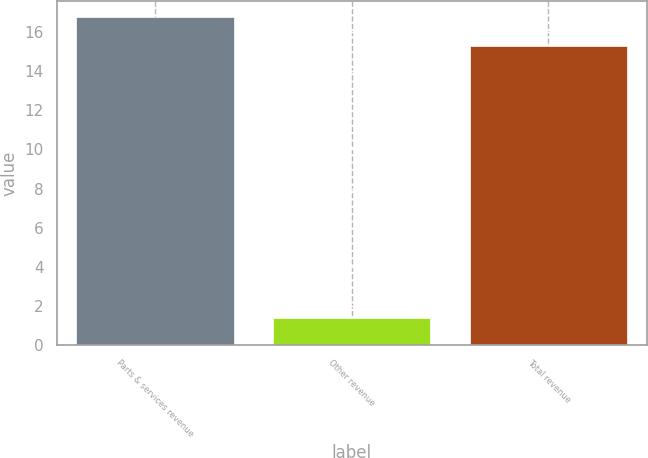Convert chart. <chart><loc_0><loc_0><loc_500><loc_500><bar_chart><fcel>Parts & services revenue<fcel>Other revenue<fcel>Total revenue<nl><fcel>16.76<fcel>1.4<fcel>15.3<nl></chart> 